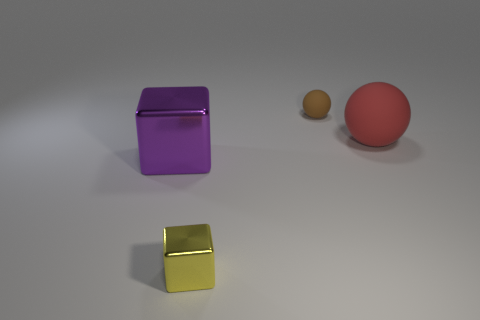There is a object that is to the left of the brown thing and to the right of the purple thing; what is its material?
Offer a terse response. Metal. Does the large purple thing have the same shape as the metal object in front of the large metal thing?
Provide a short and direct response. Yes. What material is the big thing that is to the right of the matte thing that is behind the big thing to the right of the small block made of?
Your response must be concise. Rubber. What number of other things are the same size as the red matte thing?
Make the answer very short. 1. There is a metallic cube that is in front of the big object left of the yellow metallic object; what number of large shiny blocks are to the right of it?
Offer a very short reply. 0. The small thing that is in front of the matte ball to the right of the brown thing is made of what material?
Offer a very short reply. Metal. Is there another object of the same shape as the large red rubber object?
Your answer should be very brief. Yes. What color is the sphere that is the same size as the yellow cube?
Your answer should be compact. Brown. How many things are large objects that are on the left side of the big red rubber object or things that are to the left of the large rubber ball?
Your answer should be very brief. 3. How many objects are either tiny gray rubber cubes or big objects?
Your answer should be compact. 2. 